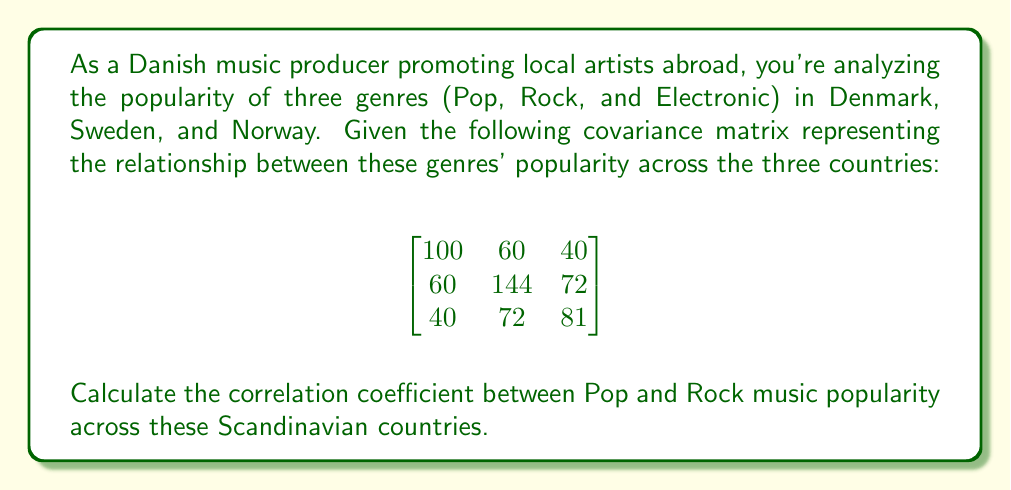Could you help me with this problem? To find the correlation coefficient between Pop and Rock music popularity, we'll follow these steps:

1. Identify the elements from the covariance matrix:
   - $Cov(Pop, Rock) = 60$
   - $Var(Pop) = 100$
   - $Var(Rock) = 144$

2. Use the formula for correlation coefficient:
   $$r = \frac{Cov(X,Y)}{\sqrt{Var(X) \cdot Var(Y)}}$$

3. Substitute the values:
   $$r = \frac{60}{\sqrt{100 \cdot 144}}$$

4. Simplify:
   $$r = \frac{60}{\sqrt{14400}} = \frac{60}{120} = 0.5$$

The correlation coefficient ranges from -1 to 1, where 1 indicates a perfect positive correlation, -1 indicates a perfect negative correlation, and 0 indicates no correlation.
Answer: $0.5$ 